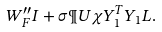<formula> <loc_0><loc_0><loc_500><loc_500>W _ { F } ^ { \prime \prime } I + \sigma \P U \chi Y _ { 1 } ^ { T } Y _ { 1 } L .</formula> 